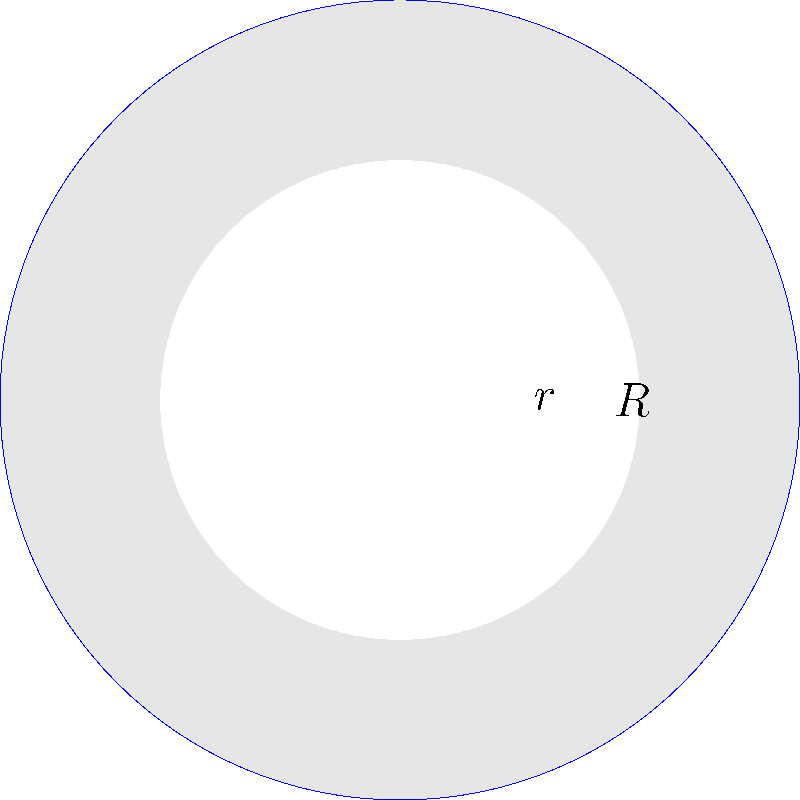In a community center project for refugees, we're designing a circular logo with two concentric circles. The outer circle has a radius of $R = 5$ cm, and the inner circle has a radius of $r = 3$ cm. What is the area of the shaded region between the two circles? Let's approach this step-by-step:

1) The shaded area is the difference between the areas of the larger and smaller circles.

2) Area of a circle is given by the formula $A = \pi r^2$, where $r$ is the radius.

3) For the larger circle:
   $A_1 = \pi R^2 = \pi (5^2) = 25\pi$ cm²

4) For the smaller circle:
   $A_2 = \pi r^2 = \pi (3^2) = 9\pi$ cm²

5) The shaded area is the difference:
   $A_{shaded} = A_1 - A_2 = 25\pi - 9\pi = 16\pi$ cm²

Therefore, the area of the shaded region is $16\pi$ square centimeters.
Answer: $16\pi$ cm² 